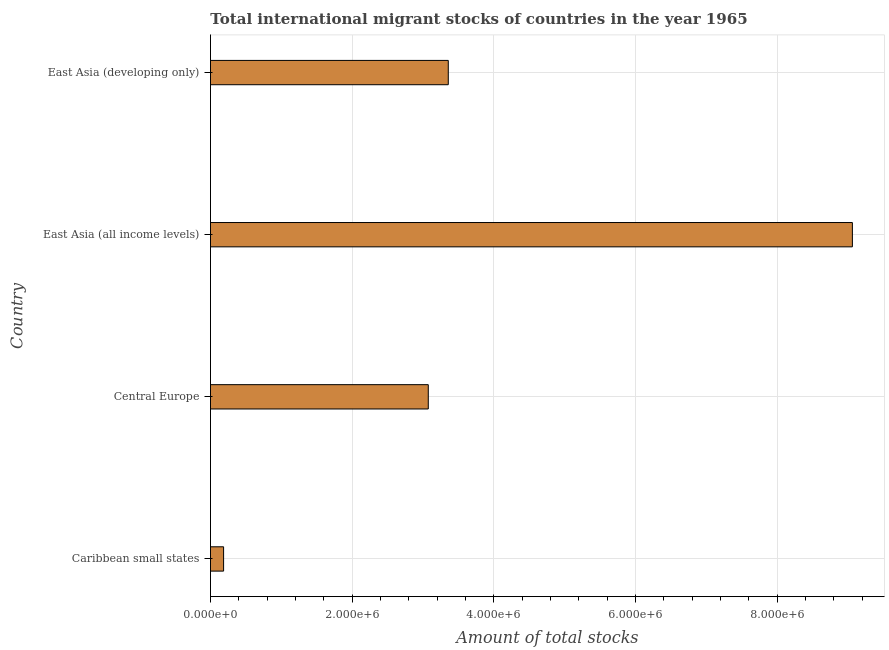What is the title of the graph?
Give a very brief answer. Total international migrant stocks of countries in the year 1965. What is the label or title of the X-axis?
Provide a short and direct response. Amount of total stocks. What is the label or title of the Y-axis?
Make the answer very short. Country. What is the total number of international migrant stock in East Asia (developing only)?
Make the answer very short. 3.36e+06. Across all countries, what is the maximum total number of international migrant stock?
Ensure brevity in your answer.  9.06e+06. Across all countries, what is the minimum total number of international migrant stock?
Your answer should be very brief. 1.85e+05. In which country was the total number of international migrant stock maximum?
Make the answer very short. East Asia (all income levels). In which country was the total number of international migrant stock minimum?
Offer a very short reply. Caribbean small states. What is the sum of the total number of international migrant stock?
Provide a succinct answer. 1.57e+07. What is the difference between the total number of international migrant stock in East Asia (all income levels) and East Asia (developing only)?
Offer a very short reply. 5.71e+06. What is the average total number of international migrant stock per country?
Offer a very short reply. 3.92e+06. What is the median total number of international migrant stock?
Your response must be concise. 3.22e+06. What is the ratio of the total number of international migrant stock in Caribbean small states to that in Central Europe?
Ensure brevity in your answer.  0.06. Is the total number of international migrant stock in Caribbean small states less than that in East Asia (all income levels)?
Your answer should be very brief. Yes. What is the difference between the highest and the second highest total number of international migrant stock?
Your response must be concise. 5.71e+06. Is the sum of the total number of international migrant stock in Central Europe and East Asia (all income levels) greater than the maximum total number of international migrant stock across all countries?
Your response must be concise. Yes. What is the difference between the highest and the lowest total number of international migrant stock?
Offer a very short reply. 8.88e+06. In how many countries, is the total number of international migrant stock greater than the average total number of international migrant stock taken over all countries?
Your answer should be very brief. 1. How many bars are there?
Make the answer very short. 4. How many countries are there in the graph?
Keep it short and to the point. 4. Are the values on the major ticks of X-axis written in scientific E-notation?
Your answer should be very brief. Yes. What is the Amount of total stocks in Caribbean small states?
Your answer should be compact. 1.85e+05. What is the Amount of total stocks in Central Europe?
Your answer should be compact. 3.08e+06. What is the Amount of total stocks of East Asia (all income levels)?
Offer a very short reply. 9.06e+06. What is the Amount of total stocks in East Asia (developing only)?
Offer a very short reply. 3.36e+06. What is the difference between the Amount of total stocks in Caribbean small states and Central Europe?
Your answer should be compact. -2.89e+06. What is the difference between the Amount of total stocks in Caribbean small states and East Asia (all income levels)?
Ensure brevity in your answer.  -8.88e+06. What is the difference between the Amount of total stocks in Caribbean small states and East Asia (developing only)?
Offer a terse response. -3.17e+06. What is the difference between the Amount of total stocks in Central Europe and East Asia (all income levels)?
Your answer should be compact. -5.99e+06. What is the difference between the Amount of total stocks in Central Europe and East Asia (developing only)?
Offer a terse response. -2.82e+05. What is the difference between the Amount of total stocks in East Asia (all income levels) and East Asia (developing only)?
Your answer should be very brief. 5.71e+06. What is the ratio of the Amount of total stocks in Caribbean small states to that in East Asia (all income levels)?
Your answer should be very brief. 0.02. What is the ratio of the Amount of total stocks in Caribbean small states to that in East Asia (developing only)?
Ensure brevity in your answer.  0.06. What is the ratio of the Amount of total stocks in Central Europe to that in East Asia (all income levels)?
Offer a very short reply. 0.34. What is the ratio of the Amount of total stocks in Central Europe to that in East Asia (developing only)?
Offer a terse response. 0.92. What is the ratio of the Amount of total stocks in East Asia (all income levels) to that in East Asia (developing only)?
Ensure brevity in your answer.  2.7. 